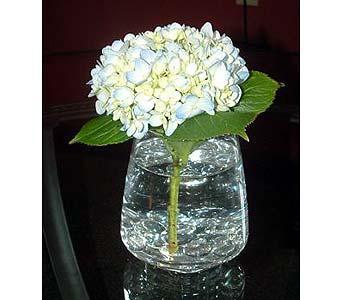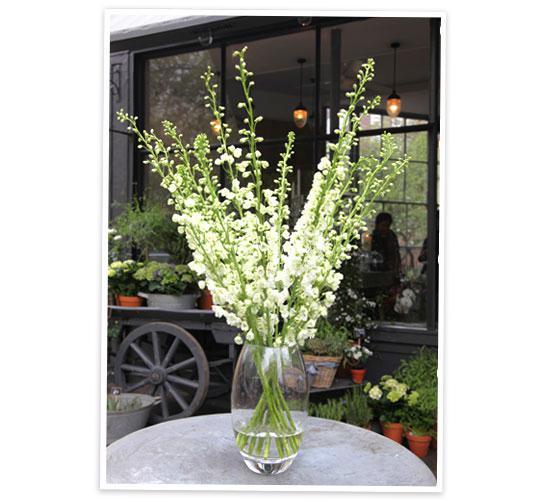The first image is the image on the left, the second image is the image on the right. For the images shown, is this caption "There are pink flowers in the vase in the image on the left." true? Answer yes or no. No. 